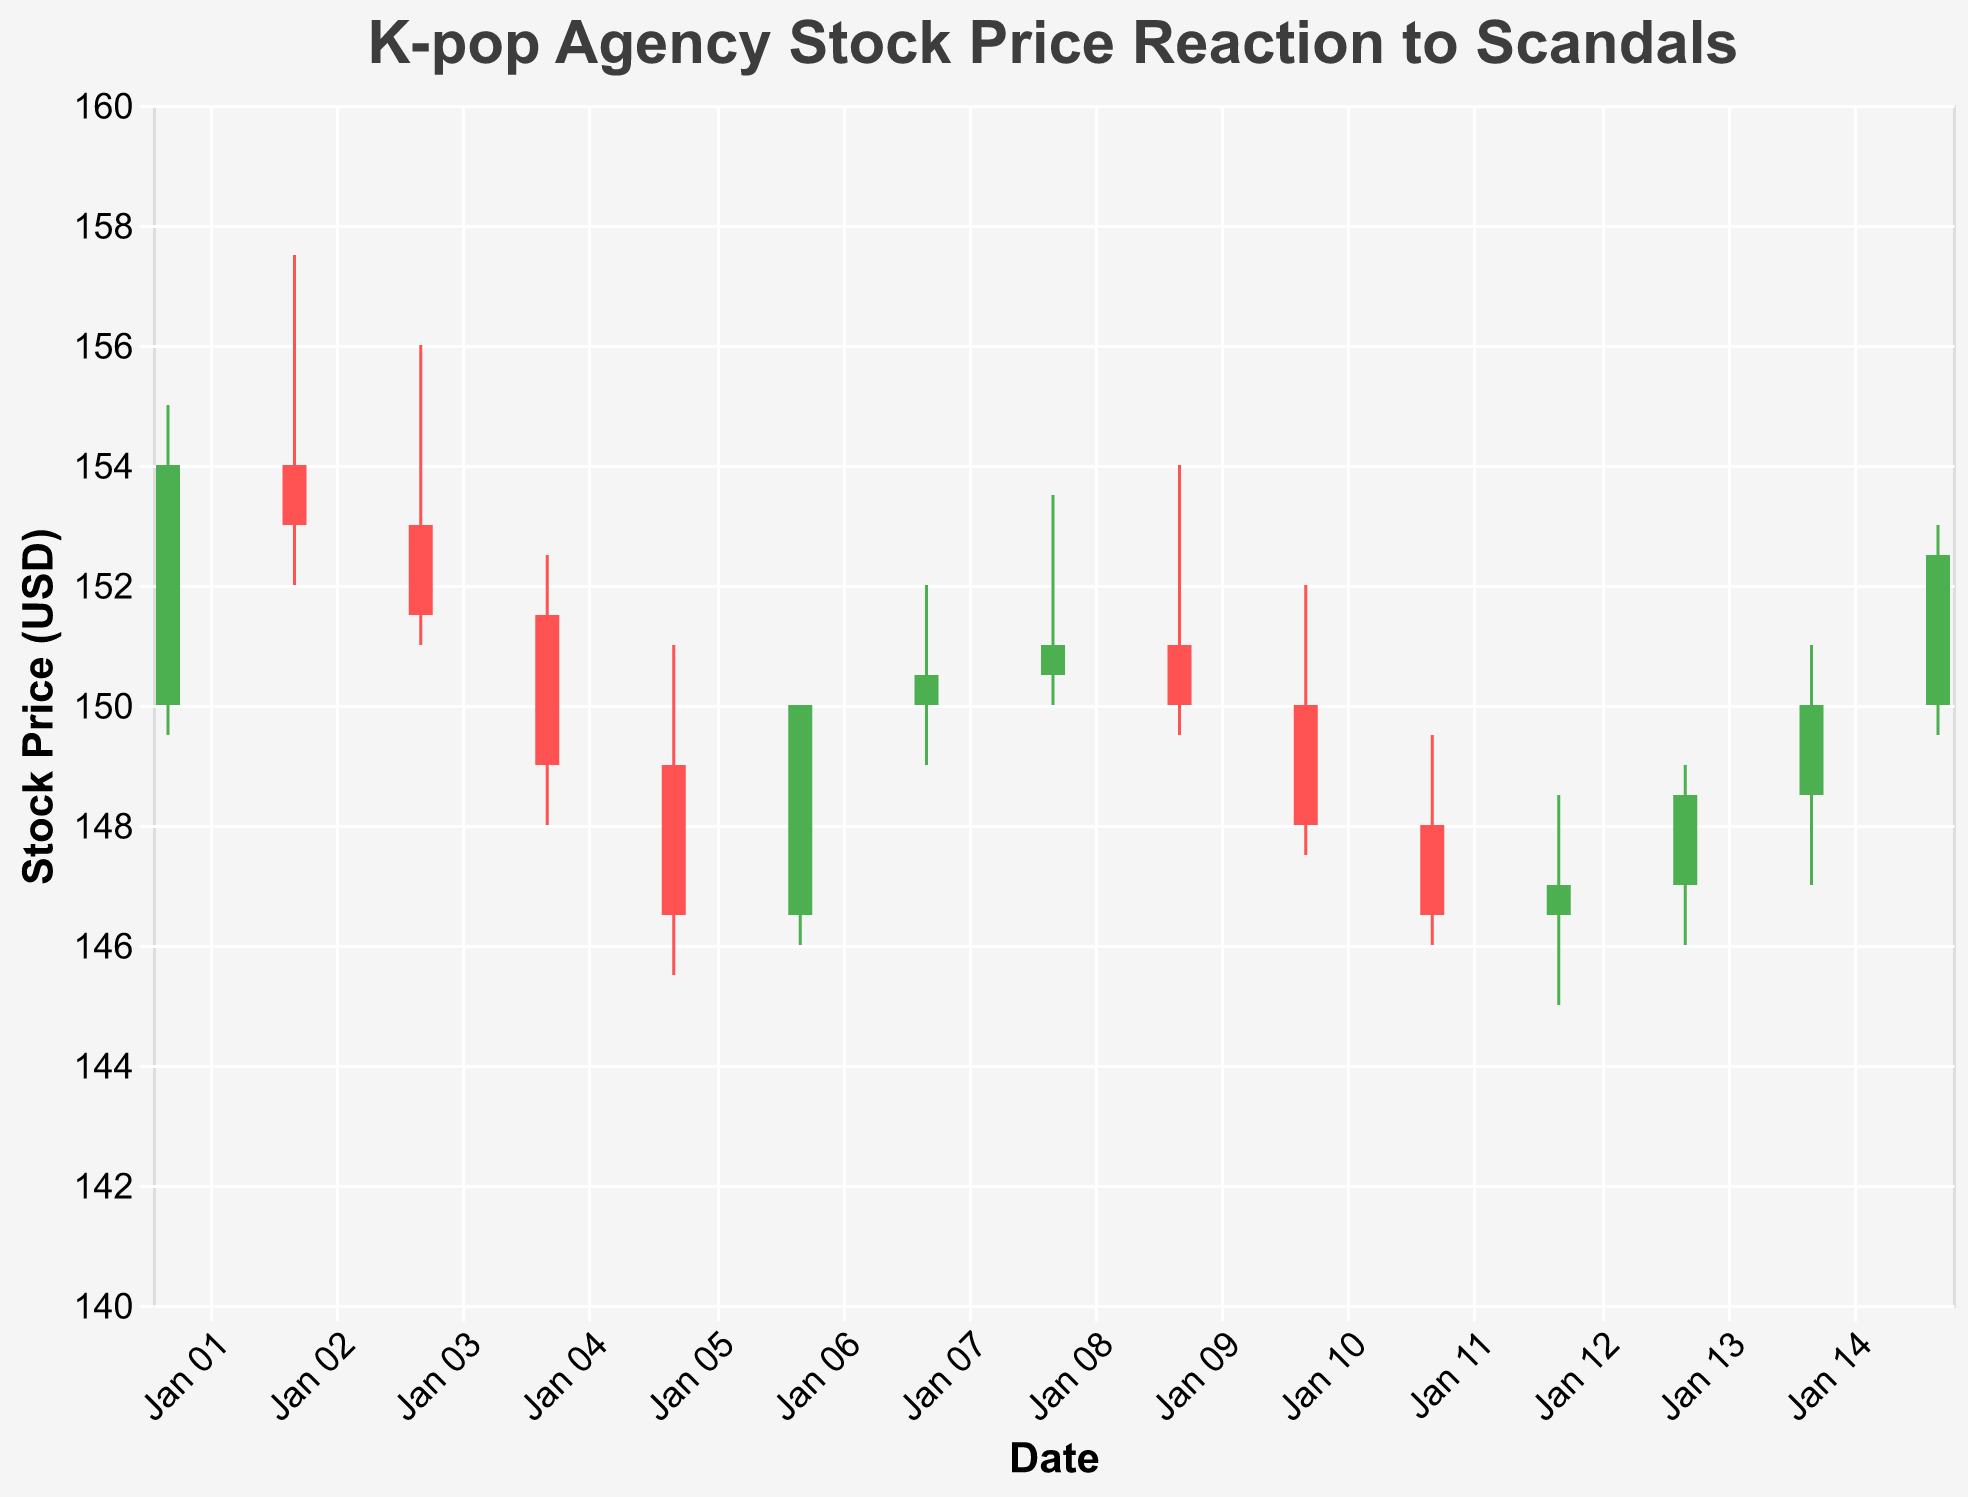How did the stock price react to the rumored dating scandal involving K-pop Idol A? On Jan 1, the closing price increased to $154.00 from the opening price of $150.00, indicating a positive reaction to the rumored dating scandal involving K-pop Idol A.
Answer: It increased What was the highest stock price recorded during the scandal involving K-pop Idol B's misconduct? On Jan 4, the highest price was $152.50, which was the day of the scandal involving K-pop Idol B's misconduct.
Answer: $152.50 Compare the stock price reaction between the K-pop Agency C CEO controversy and the K-pop Idol D being found innocent. Which resulted in a higher final closing price? On Jan 7 (CEO controversy), the closing price was $150.50. On Jan 10 (Idol D found innocent), the closing price was $148.00. Therefore, the CEO controversy resulted in a higher final closing price.
Answer: CEO controversy By how much did the volume increase on the day of the scandal involving K-pop Idol B's misconduct compared to the previous day? On Jan 4, the volume was 700,000, and on Jan 3, it was 600,000. The increase in volume was 700,000 - 600,000 = 100,000.
Answer: 100,000 Calculate the average closing price of the stock from Jan 1 to Jan 5. The closing prices are $154.00, $153.00, $151.50, $149.00, and $146.50. The sum is 154.00 + 153.00 + 151.50 + 149.00 + 146.50 = 754.00, and the average is 754.00 / 5 = 150.80.
Answer: $150.80 Which event had the greatest negative impact on the stock price in terms of the drop from the opening to the closing price? The scandal involving K-pop Idol B's misconduct on Jan 4 saw the stock drop from $151.50 to $149.00, a decrease of $2.50, which was the largest drop.
Answer: Idol B's misconduct What is the minimum stock price recorded in the entire period shown in the plot? On Jan 5, the minimum stock price recorded was $145.50.
Answer: $145.50 During the period of Jan 7 to Jan 12, which day had the highest trading volume, and what was the volume? On Jan 10, the trading volume was 600,000, which was the highest during this period.
Answer: Jan 10, 600,000 